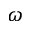Convert formula to latex. <formula><loc_0><loc_0><loc_500><loc_500>\omega</formula> 